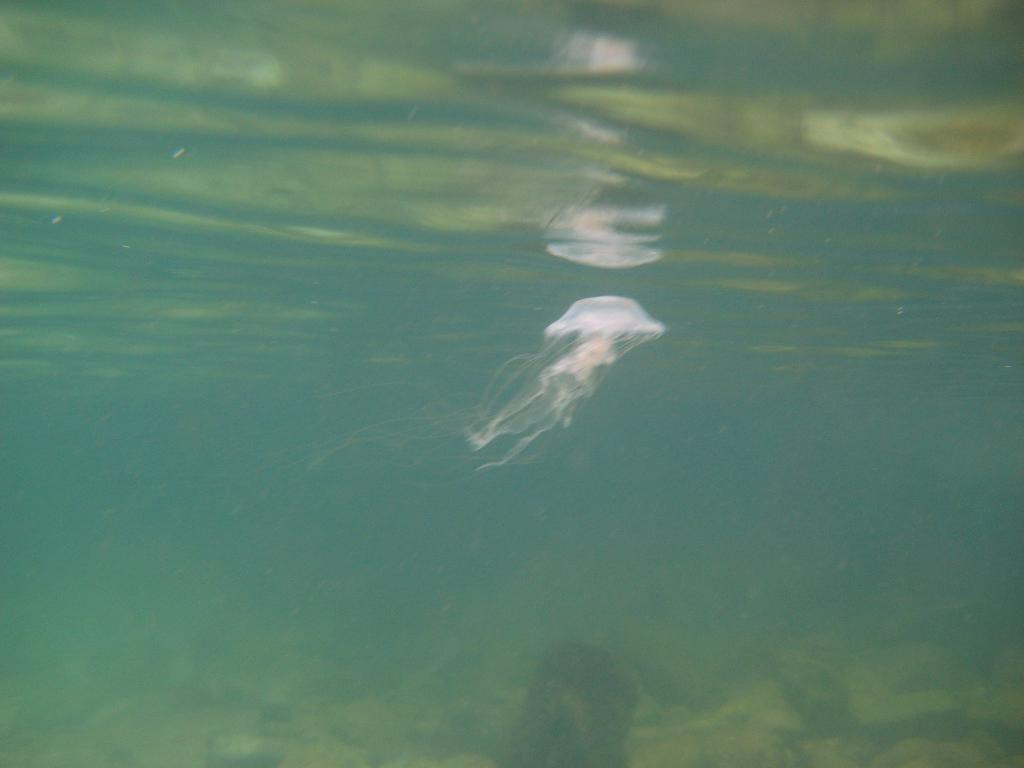What is the setting of the image? The image shows a view deep inside the water. What can be seen in the water besides the jellyfish? There are rocks visible in the water, and there is a path in the water. What type of marine creature is present in the image? A jellyfish is present in the image, and it is white in color. What type of landmarks can be seen in the image? There are no landmarks present in the image, as it is set deep inside the water. What holiday is being celebrated in the image? There is no indication of a holiday being celebrated in the image. 